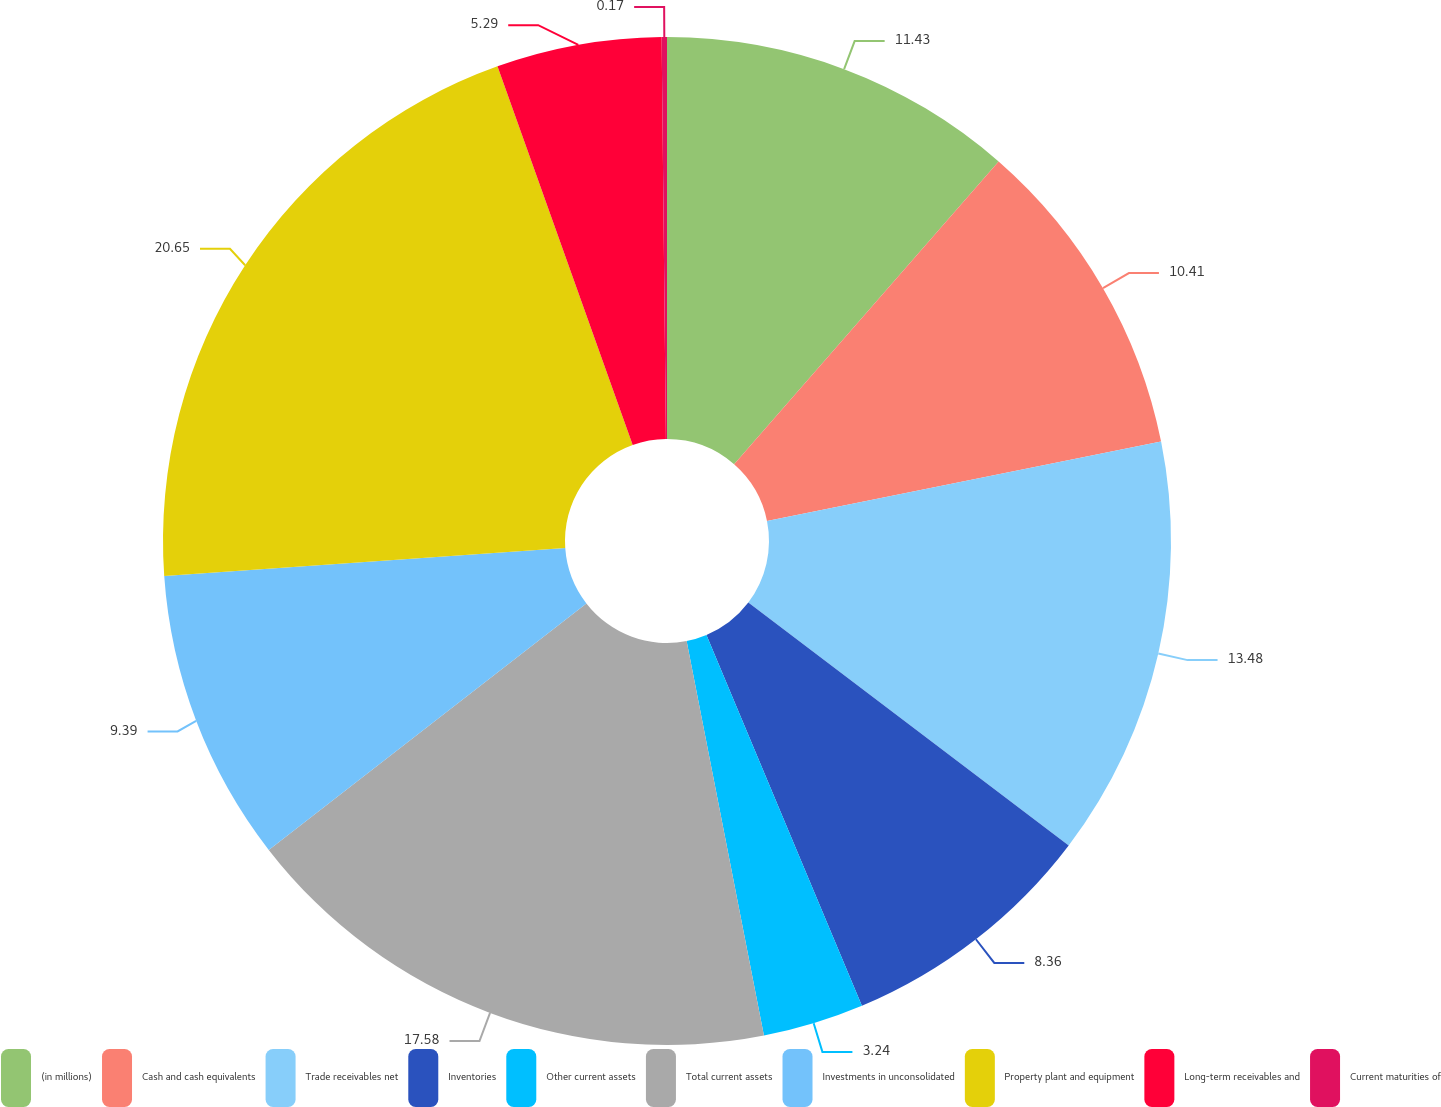Convert chart. <chart><loc_0><loc_0><loc_500><loc_500><pie_chart><fcel>(in millions)<fcel>Cash and cash equivalents<fcel>Trade receivables net<fcel>Inventories<fcel>Other current assets<fcel>Total current assets<fcel>Investments in unconsolidated<fcel>Property plant and equipment<fcel>Long-term receivables and<fcel>Current maturities of<nl><fcel>11.43%<fcel>10.41%<fcel>13.48%<fcel>8.36%<fcel>3.24%<fcel>17.58%<fcel>9.39%<fcel>20.65%<fcel>5.29%<fcel>0.17%<nl></chart> 